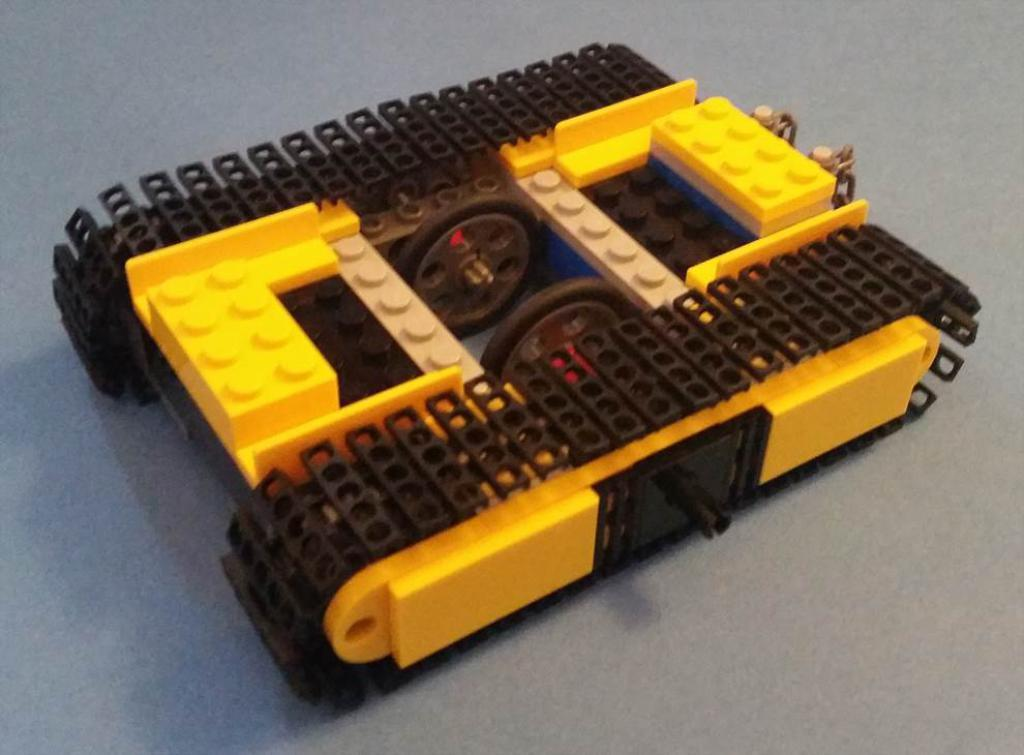What is the main subject of the image? The main subject of the image is a vehicle made of lego. What is the surface on which the vehicle is placed? The vehicle is on an ash-colored surface. How many people are in the crowd surrounding the lego vehicle in the image? There is no crowd present in the image; it only features a lego vehicle on an ash-colored surface. 